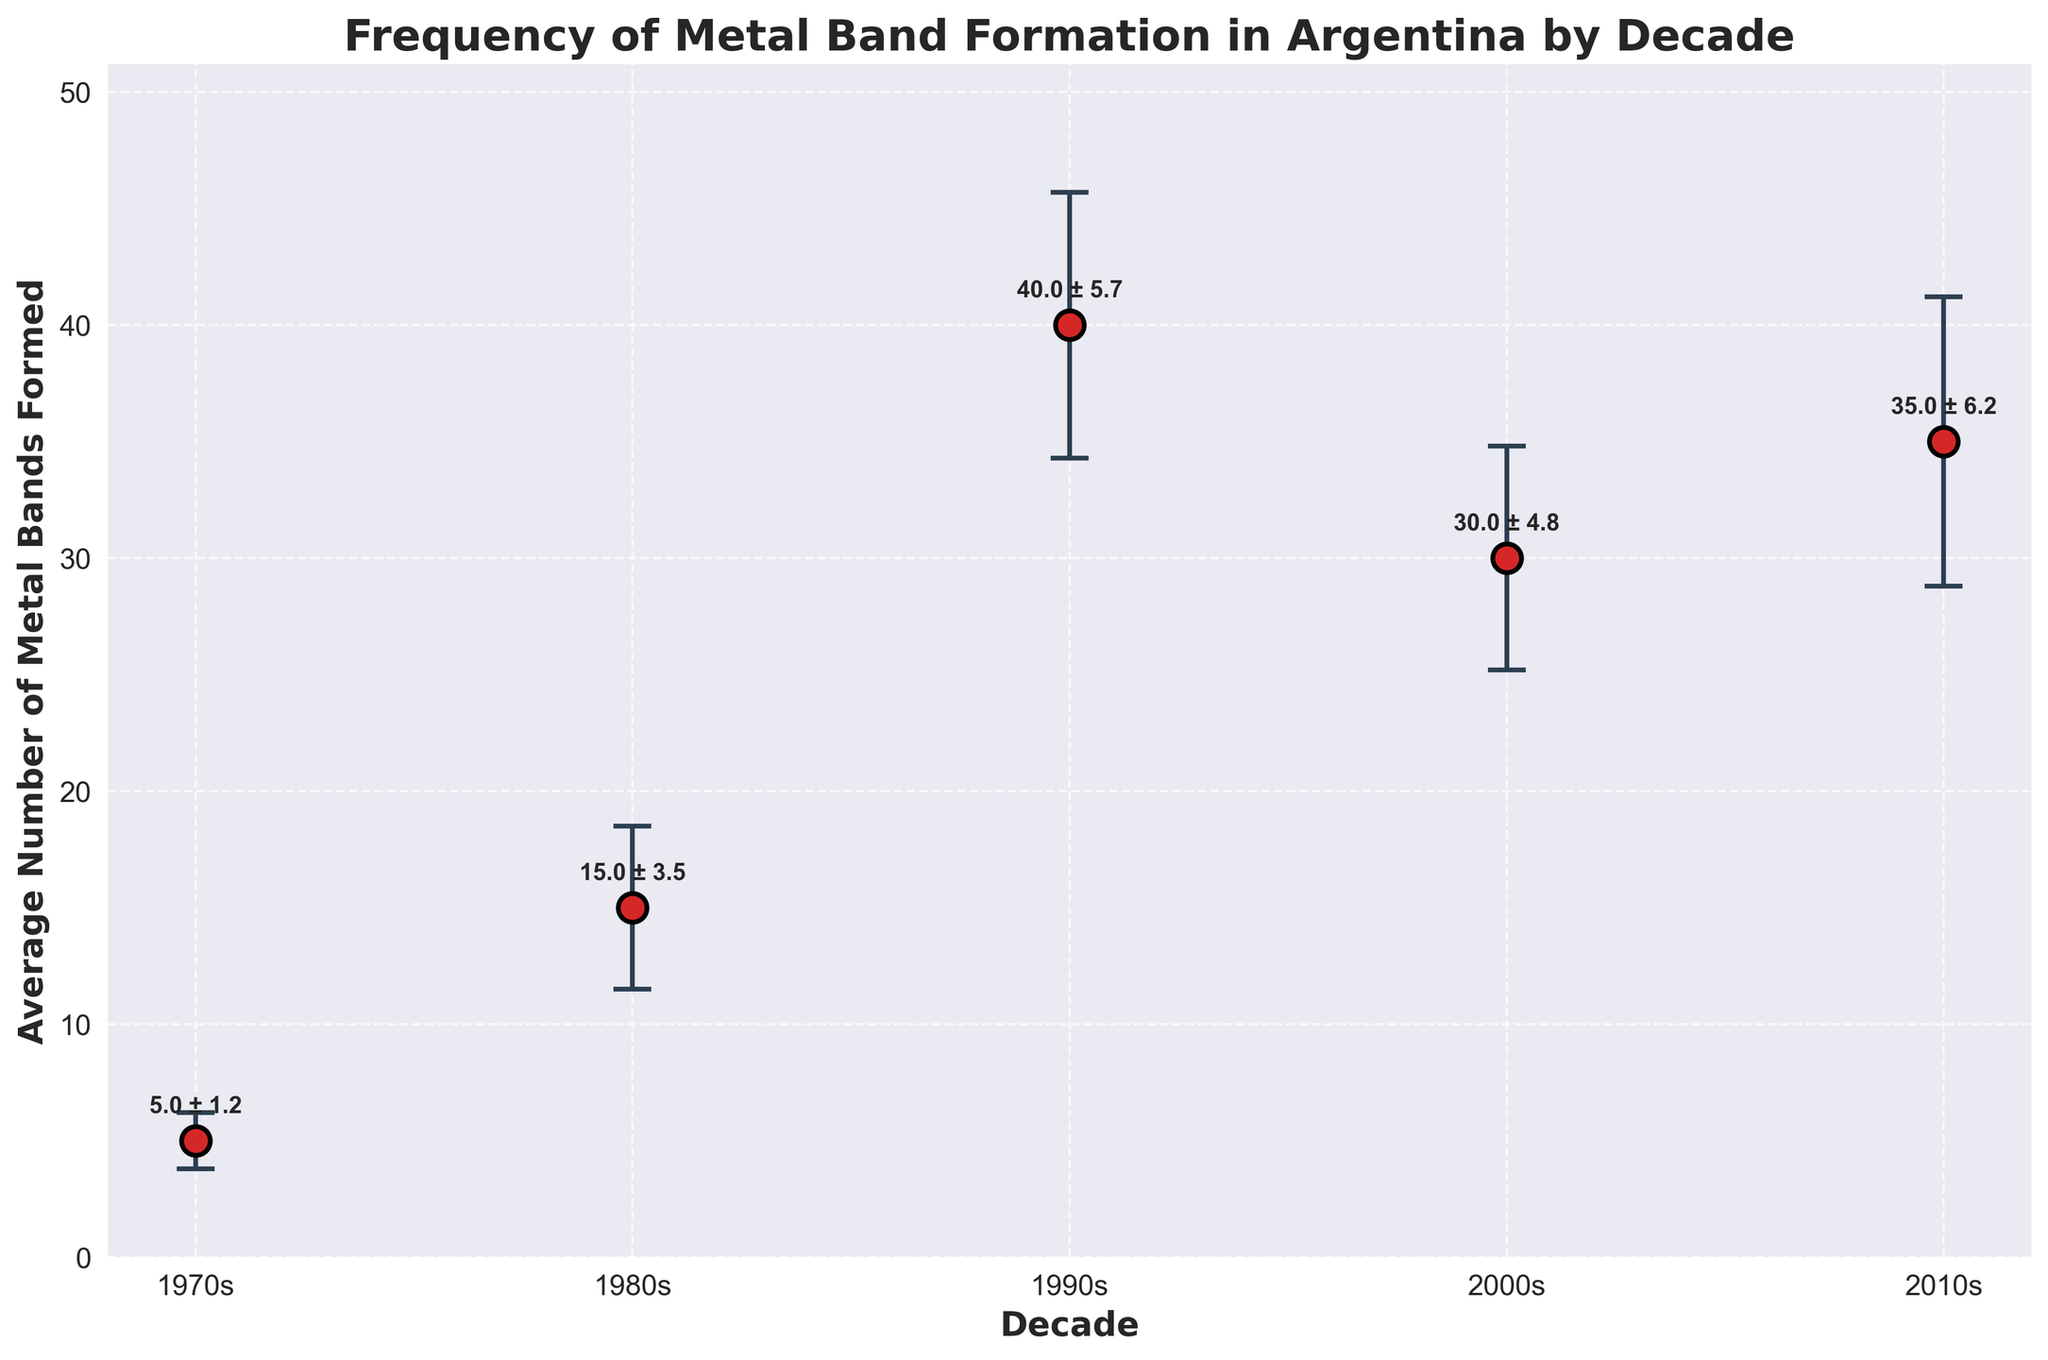What's the title of the figure? The title of the figure is displayed at the top. It reads "Frequency of Metal Band Formation in Argentina by Decade".
Answer: Frequency of Metal Band Formation in Argentina by Decade How many decades are shown in the figure? The figure includes five distinct data points, each representing a different decade.
Answer: Five Which decade saw the highest average number of metal bands formed? The highest mean value is represented by the dot at the topmost point on the y-axis, which corresponds to the 1990s.
Answer: 1990s What's the average number of bands formed in the 2000s? From the annotated points, the average number of bands formed in the 2000s is directly labeled as 30.0.
Answer: 30 Which decade has the largest error bar range? By visually comparing the lengths of the error bars, the decade with the longest error bar is the 2010s, as its error bar extends the furthest vertically.
Answer: 2010s What's the difference in the average number of bands formed between the 1980s and 2000s? Subtract the mean value of the 1980s (15) from the mean value of the 2000s (30): 30 - 15 = 15.
Answer: 15 In which decade was the frequency of metal band formations the most uncertain (largest standard deviation)? The standard deviations can be inferred from the lengths of the error bars. The 2010s has the largest error bar, indicating the largest standard deviation.
Answer: 2010s How does the mean number of bands formed in the 2010s compare to that in the 2000s? By looking at the y-values of both decades, the 2010s (35) has a higher mean compared to the 2000s (30).
Answer: Higher What's the combined average number of bands formed in the 1970s and 1980s? Sum the average values for the 1970s (5) and 1980s (15): 5 + 15 = 20.
Answer: 20 During which decade did the average number of bands formed decrease compared to the previous decade? By comparing successive decades, the average number of bands formed decreases from the 1990s (40) to the 2000s (30).
Answer: 2000s 